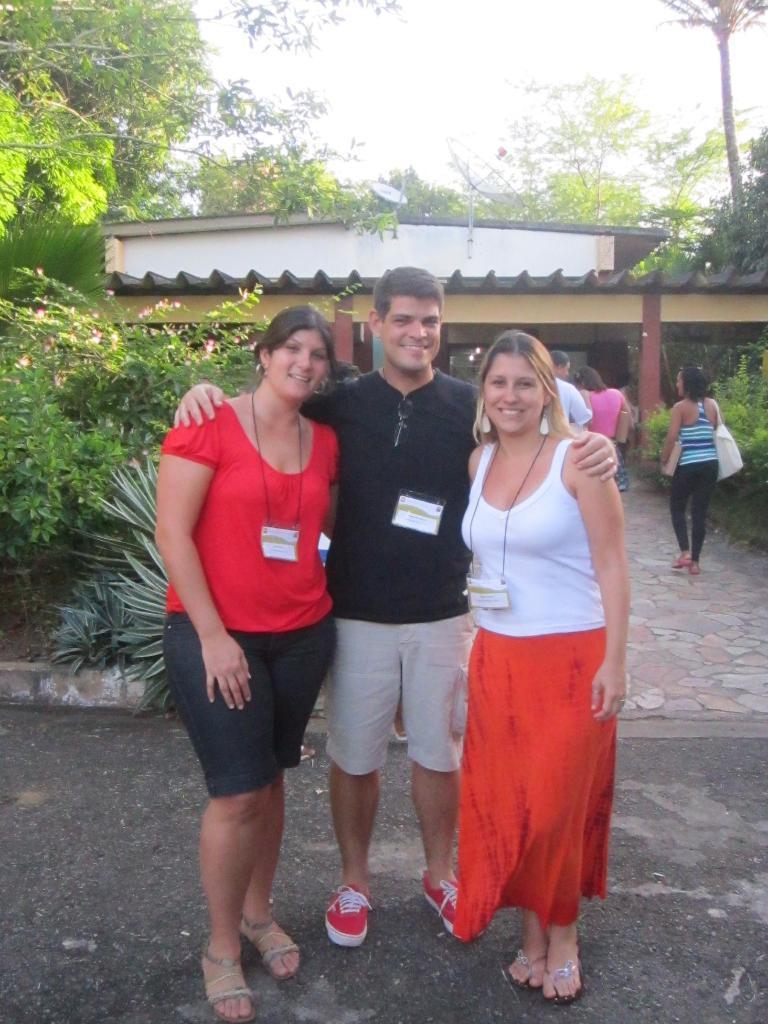How would you summarize this image in a sentence or two? In this picture we can see three people wore id cards, standing on the floor, smiling and at the back of them we can see some people, shed, trees and in the background we can see the sky. 